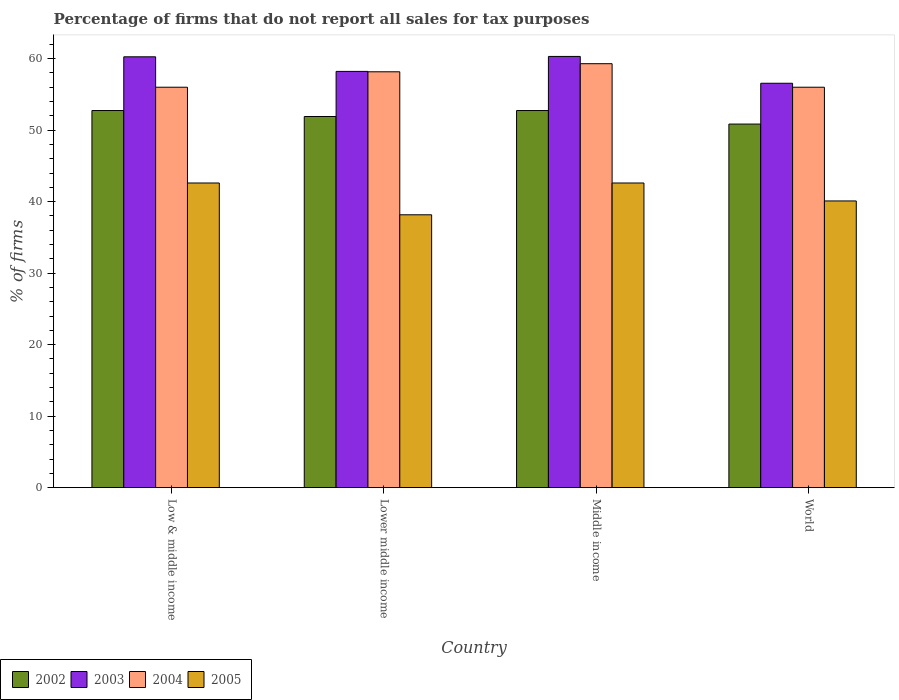How many different coloured bars are there?
Ensure brevity in your answer.  4. Are the number of bars per tick equal to the number of legend labels?
Your answer should be compact. Yes. Are the number of bars on each tick of the X-axis equal?
Your answer should be compact. Yes. How many bars are there on the 3rd tick from the left?
Provide a short and direct response. 4. What is the label of the 3rd group of bars from the left?
Provide a succinct answer. Middle income. What is the percentage of firms that do not report all sales for tax purposes in 2004 in Lower middle income?
Your response must be concise. 58.16. Across all countries, what is the maximum percentage of firms that do not report all sales for tax purposes in 2005?
Offer a very short reply. 42.61. Across all countries, what is the minimum percentage of firms that do not report all sales for tax purposes in 2004?
Your answer should be compact. 56.01. In which country was the percentage of firms that do not report all sales for tax purposes in 2002 minimum?
Offer a very short reply. World. What is the total percentage of firms that do not report all sales for tax purposes in 2003 in the graph?
Your response must be concise. 235.35. What is the difference between the percentage of firms that do not report all sales for tax purposes in 2004 in Lower middle income and that in Middle income?
Provide a succinct answer. -1.13. What is the difference between the percentage of firms that do not report all sales for tax purposes in 2003 in Lower middle income and the percentage of firms that do not report all sales for tax purposes in 2004 in World?
Give a very brief answer. 2.21. What is the average percentage of firms that do not report all sales for tax purposes in 2003 per country?
Offer a terse response. 58.84. What is the difference between the percentage of firms that do not report all sales for tax purposes of/in 2004 and percentage of firms that do not report all sales for tax purposes of/in 2003 in Lower middle income?
Provide a short and direct response. -0.05. In how many countries, is the percentage of firms that do not report all sales for tax purposes in 2002 greater than 18 %?
Give a very brief answer. 4. What is the ratio of the percentage of firms that do not report all sales for tax purposes in 2005 in Low & middle income to that in World?
Your response must be concise. 1.06. What is the difference between the highest and the second highest percentage of firms that do not report all sales for tax purposes in 2005?
Your answer should be very brief. -2.51. What is the difference between the highest and the lowest percentage of firms that do not report all sales for tax purposes in 2002?
Provide a succinct answer. 1.89. In how many countries, is the percentage of firms that do not report all sales for tax purposes in 2003 greater than the average percentage of firms that do not report all sales for tax purposes in 2003 taken over all countries?
Keep it short and to the point. 2. What does the 3rd bar from the left in Middle income represents?
Make the answer very short. 2004. How many bars are there?
Your answer should be very brief. 16. Does the graph contain any zero values?
Provide a succinct answer. No. Does the graph contain grids?
Offer a very short reply. No. Where does the legend appear in the graph?
Ensure brevity in your answer.  Bottom left. What is the title of the graph?
Offer a terse response. Percentage of firms that do not report all sales for tax purposes. Does "1973" appear as one of the legend labels in the graph?
Provide a short and direct response. No. What is the label or title of the X-axis?
Offer a terse response. Country. What is the label or title of the Y-axis?
Make the answer very short. % of firms. What is the % of firms of 2002 in Low & middle income?
Offer a very short reply. 52.75. What is the % of firms in 2003 in Low & middle income?
Give a very brief answer. 60.26. What is the % of firms of 2004 in Low & middle income?
Provide a succinct answer. 56.01. What is the % of firms in 2005 in Low & middle income?
Your answer should be very brief. 42.61. What is the % of firms of 2002 in Lower middle income?
Offer a very short reply. 51.91. What is the % of firms in 2003 in Lower middle income?
Make the answer very short. 58.22. What is the % of firms of 2004 in Lower middle income?
Your answer should be very brief. 58.16. What is the % of firms in 2005 in Lower middle income?
Offer a very short reply. 38.16. What is the % of firms of 2002 in Middle income?
Offer a terse response. 52.75. What is the % of firms of 2003 in Middle income?
Ensure brevity in your answer.  60.31. What is the % of firms of 2004 in Middle income?
Make the answer very short. 59.3. What is the % of firms in 2005 in Middle income?
Give a very brief answer. 42.61. What is the % of firms of 2002 in World?
Your answer should be very brief. 50.85. What is the % of firms in 2003 in World?
Give a very brief answer. 56.56. What is the % of firms in 2004 in World?
Your answer should be very brief. 56.01. What is the % of firms in 2005 in World?
Make the answer very short. 40.1. Across all countries, what is the maximum % of firms of 2002?
Your answer should be very brief. 52.75. Across all countries, what is the maximum % of firms of 2003?
Your answer should be compact. 60.31. Across all countries, what is the maximum % of firms of 2004?
Give a very brief answer. 59.3. Across all countries, what is the maximum % of firms of 2005?
Offer a terse response. 42.61. Across all countries, what is the minimum % of firms of 2002?
Offer a terse response. 50.85. Across all countries, what is the minimum % of firms of 2003?
Your response must be concise. 56.56. Across all countries, what is the minimum % of firms of 2004?
Provide a succinct answer. 56.01. Across all countries, what is the minimum % of firms of 2005?
Your answer should be compact. 38.16. What is the total % of firms in 2002 in the graph?
Keep it short and to the point. 208.25. What is the total % of firms in 2003 in the graph?
Keep it short and to the point. 235.35. What is the total % of firms of 2004 in the graph?
Make the answer very short. 229.47. What is the total % of firms in 2005 in the graph?
Offer a very short reply. 163.48. What is the difference between the % of firms of 2002 in Low & middle income and that in Lower middle income?
Ensure brevity in your answer.  0.84. What is the difference between the % of firms in 2003 in Low & middle income and that in Lower middle income?
Offer a very short reply. 2.04. What is the difference between the % of firms of 2004 in Low & middle income and that in Lower middle income?
Make the answer very short. -2.16. What is the difference between the % of firms in 2005 in Low & middle income and that in Lower middle income?
Offer a terse response. 4.45. What is the difference between the % of firms of 2002 in Low & middle income and that in Middle income?
Make the answer very short. 0. What is the difference between the % of firms of 2003 in Low & middle income and that in Middle income?
Provide a succinct answer. -0.05. What is the difference between the % of firms in 2004 in Low & middle income and that in Middle income?
Keep it short and to the point. -3.29. What is the difference between the % of firms in 2005 in Low & middle income and that in Middle income?
Your answer should be very brief. 0. What is the difference between the % of firms in 2002 in Low & middle income and that in World?
Offer a very short reply. 1.89. What is the difference between the % of firms in 2005 in Low & middle income and that in World?
Ensure brevity in your answer.  2.51. What is the difference between the % of firms in 2002 in Lower middle income and that in Middle income?
Give a very brief answer. -0.84. What is the difference between the % of firms of 2003 in Lower middle income and that in Middle income?
Give a very brief answer. -2.09. What is the difference between the % of firms of 2004 in Lower middle income and that in Middle income?
Provide a short and direct response. -1.13. What is the difference between the % of firms of 2005 in Lower middle income and that in Middle income?
Offer a very short reply. -4.45. What is the difference between the % of firms of 2002 in Lower middle income and that in World?
Your response must be concise. 1.06. What is the difference between the % of firms of 2003 in Lower middle income and that in World?
Your answer should be very brief. 1.66. What is the difference between the % of firms in 2004 in Lower middle income and that in World?
Your answer should be compact. 2.16. What is the difference between the % of firms in 2005 in Lower middle income and that in World?
Provide a succinct answer. -1.94. What is the difference between the % of firms of 2002 in Middle income and that in World?
Keep it short and to the point. 1.89. What is the difference between the % of firms of 2003 in Middle income and that in World?
Offer a terse response. 3.75. What is the difference between the % of firms in 2004 in Middle income and that in World?
Make the answer very short. 3.29. What is the difference between the % of firms of 2005 in Middle income and that in World?
Your answer should be very brief. 2.51. What is the difference between the % of firms of 2002 in Low & middle income and the % of firms of 2003 in Lower middle income?
Make the answer very short. -5.47. What is the difference between the % of firms in 2002 in Low & middle income and the % of firms in 2004 in Lower middle income?
Ensure brevity in your answer.  -5.42. What is the difference between the % of firms of 2002 in Low & middle income and the % of firms of 2005 in Lower middle income?
Your answer should be compact. 14.58. What is the difference between the % of firms in 2003 in Low & middle income and the % of firms in 2004 in Lower middle income?
Ensure brevity in your answer.  2.1. What is the difference between the % of firms in 2003 in Low & middle income and the % of firms in 2005 in Lower middle income?
Provide a succinct answer. 22.1. What is the difference between the % of firms of 2004 in Low & middle income and the % of firms of 2005 in Lower middle income?
Give a very brief answer. 17.84. What is the difference between the % of firms of 2002 in Low & middle income and the % of firms of 2003 in Middle income?
Provide a succinct answer. -7.57. What is the difference between the % of firms of 2002 in Low & middle income and the % of firms of 2004 in Middle income?
Give a very brief answer. -6.55. What is the difference between the % of firms of 2002 in Low & middle income and the % of firms of 2005 in Middle income?
Offer a terse response. 10.13. What is the difference between the % of firms in 2003 in Low & middle income and the % of firms in 2005 in Middle income?
Offer a terse response. 17.65. What is the difference between the % of firms of 2004 in Low & middle income and the % of firms of 2005 in Middle income?
Your answer should be very brief. 13.39. What is the difference between the % of firms in 2002 in Low & middle income and the % of firms in 2003 in World?
Keep it short and to the point. -3.81. What is the difference between the % of firms in 2002 in Low & middle income and the % of firms in 2004 in World?
Provide a succinct answer. -3.26. What is the difference between the % of firms in 2002 in Low & middle income and the % of firms in 2005 in World?
Ensure brevity in your answer.  12.65. What is the difference between the % of firms in 2003 in Low & middle income and the % of firms in 2004 in World?
Offer a very short reply. 4.25. What is the difference between the % of firms in 2003 in Low & middle income and the % of firms in 2005 in World?
Keep it short and to the point. 20.16. What is the difference between the % of firms of 2004 in Low & middle income and the % of firms of 2005 in World?
Your answer should be very brief. 15.91. What is the difference between the % of firms in 2002 in Lower middle income and the % of firms in 2003 in Middle income?
Your response must be concise. -8.4. What is the difference between the % of firms in 2002 in Lower middle income and the % of firms in 2004 in Middle income?
Give a very brief answer. -7.39. What is the difference between the % of firms of 2002 in Lower middle income and the % of firms of 2005 in Middle income?
Ensure brevity in your answer.  9.3. What is the difference between the % of firms of 2003 in Lower middle income and the % of firms of 2004 in Middle income?
Offer a terse response. -1.08. What is the difference between the % of firms of 2003 in Lower middle income and the % of firms of 2005 in Middle income?
Your response must be concise. 15.61. What is the difference between the % of firms of 2004 in Lower middle income and the % of firms of 2005 in Middle income?
Your answer should be compact. 15.55. What is the difference between the % of firms of 2002 in Lower middle income and the % of firms of 2003 in World?
Offer a very short reply. -4.65. What is the difference between the % of firms in 2002 in Lower middle income and the % of firms in 2004 in World?
Provide a short and direct response. -4.1. What is the difference between the % of firms of 2002 in Lower middle income and the % of firms of 2005 in World?
Offer a very short reply. 11.81. What is the difference between the % of firms of 2003 in Lower middle income and the % of firms of 2004 in World?
Give a very brief answer. 2.21. What is the difference between the % of firms of 2003 in Lower middle income and the % of firms of 2005 in World?
Provide a succinct answer. 18.12. What is the difference between the % of firms in 2004 in Lower middle income and the % of firms in 2005 in World?
Offer a terse response. 18.07. What is the difference between the % of firms in 2002 in Middle income and the % of firms in 2003 in World?
Ensure brevity in your answer.  -3.81. What is the difference between the % of firms in 2002 in Middle income and the % of firms in 2004 in World?
Keep it short and to the point. -3.26. What is the difference between the % of firms of 2002 in Middle income and the % of firms of 2005 in World?
Your response must be concise. 12.65. What is the difference between the % of firms of 2003 in Middle income and the % of firms of 2004 in World?
Provide a short and direct response. 4.31. What is the difference between the % of firms in 2003 in Middle income and the % of firms in 2005 in World?
Offer a terse response. 20.21. What is the difference between the % of firms in 2004 in Middle income and the % of firms in 2005 in World?
Offer a terse response. 19.2. What is the average % of firms in 2002 per country?
Provide a short and direct response. 52.06. What is the average % of firms in 2003 per country?
Offer a terse response. 58.84. What is the average % of firms of 2004 per country?
Your answer should be very brief. 57.37. What is the average % of firms in 2005 per country?
Provide a short and direct response. 40.87. What is the difference between the % of firms in 2002 and % of firms in 2003 in Low & middle income?
Keep it short and to the point. -7.51. What is the difference between the % of firms of 2002 and % of firms of 2004 in Low & middle income?
Provide a short and direct response. -3.26. What is the difference between the % of firms of 2002 and % of firms of 2005 in Low & middle income?
Provide a succinct answer. 10.13. What is the difference between the % of firms in 2003 and % of firms in 2004 in Low & middle income?
Keep it short and to the point. 4.25. What is the difference between the % of firms of 2003 and % of firms of 2005 in Low & middle income?
Your answer should be very brief. 17.65. What is the difference between the % of firms in 2004 and % of firms in 2005 in Low & middle income?
Provide a succinct answer. 13.39. What is the difference between the % of firms in 2002 and % of firms in 2003 in Lower middle income?
Give a very brief answer. -6.31. What is the difference between the % of firms of 2002 and % of firms of 2004 in Lower middle income?
Keep it short and to the point. -6.26. What is the difference between the % of firms of 2002 and % of firms of 2005 in Lower middle income?
Provide a succinct answer. 13.75. What is the difference between the % of firms in 2003 and % of firms in 2004 in Lower middle income?
Your response must be concise. 0.05. What is the difference between the % of firms of 2003 and % of firms of 2005 in Lower middle income?
Your answer should be compact. 20.06. What is the difference between the % of firms in 2004 and % of firms in 2005 in Lower middle income?
Provide a short and direct response. 20. What is the difference between the % of firms of 2002 and % of firms of 2003 in Middle income?
Your response must be concise. -7.57. What is the difference between the % of firms in 2002 and % of firms in 2004 in Middle income?
Make the answer very short. -6.55. What is the difference between the % of firms in 2002 and % of firms in 2005 in Middle income?
Keep it short and to the point. 10.13. What is the difference between the % of firms in 2003 and % of firms in 2004 in Middle income?
Keep it short and to the point. 1.02. What is the difference between the % of firms in 2003 and % of firms in 2005 in Middle income?
Provide a short and direct response. 17.7. What is the difference between the % of firms in 2004 and % of firms in 2005 in Middle income?
Keep it short and to the point. 16.69. What is the difference between the % of firms of 2002 and % of firms of 2003 in World?
Ensure brevity in your answer.  -5.71. What is the difference between the % of firms of 2002 and % of firms of 2004 in World?
Make the answer very short. -5.15. What is the difference between the % of firms in 2002 and % of firms in 2005 in World?
Offer a very short reply. 10.75. What is the difference between the % of firms in 2003 and % of firms in 2004 in World?
Provide a short and direct response. 0.56. What is the difference between the % of firms in 2003 and % of firms in 2005 in World?
Your response must be concise. 16.46. What is the difference between the % of firms of 2004 and % of firms of 2005 in World?
Offer a very short reply. 15.91. What is the ratio of the % of firms of 2002 in Low & middle income to that in Lower middle income?
Your answer should be very brief. 1.02. What is the ratio of the % of firms of 2003 in Low & middle income to that in Lower middle income?
Ensure brevity in your answer.  1.04. What is the ratio of the % of firms of 2004 in Low & middle income to that in Lower middle income?
Give a very brief answer. 0.96. What is the ratio of the % of firms of 2005 in Low & middle income to that in Lower middle income?
Provide a short and direct response. 1.12. What is the ratio of the % of firms of 2003 in Low & middle income to that in Middle income?
Your answer should be compact. 1. What is the ratio of the % of firms in 2004 in Low & middle income to that in Middle income?
Your answer should be compact. 0.94. What is the ratio of the % of firms in 2005 in Low & middle income to that in Middle income?
Offer a terse response. 1. What is the ratio of the % of firms of 2002 in Low & middle income to that in World?
Give a very brief answer. 1.04. What is the ratio of the % of firms of 2003 in Low & middle income to that in World?
Offer a very short reply. 1.07. What is the ratio of the % of firms in 2004 in Low & middle income to that in World?
Make the answer very short. 1. What is the ratio of the % of firms in 2005 in Low & middle income to that in World?
Your response must be concise. 1.06. What is the ratio of the % of firms in 2002 in Lower middle income to that in Middle income?
Offer a very short reply. 0.98. What is the ratio of the % of firms in 2003 in Lower middle income to that in Middle income?
Your answer should be very brief. 0.97. What is the ratio of the % of firms in 2004 in Lower middle income to that in Middle income?
Offer a terse response. 0.98. What is the ratio of the % of firms of 2005 in Lower middle income to that in Middle income?
Provide a short and direct response. 0.9. What is the ratio of the % of firms in 2002 in Lower middle income to that in World?
Provide a succinct answer. 1.02. What is the ratio of the % of firms in 2003 in Lower middle income to that in World?
Ensure brevity in your answer.  1.03. What is the ratio of the % of firms of 2004 in Lower middle income to that in World?
Keep it short and to the point. 1.04. What is the ratio of the % of firms in 2005 in Lower middle income to that in World?
Make the answer very short. 0.95. What is the ratio of the % of firms of 2002 in Middle income to that in World?
Your answer should be compact. 1.04. What is the ratio of the % of firms in 2003 in Middle income to that in World?
Your answer should be compact. 1.07. What is the ratio of the % of firms in 2004 in Middle income to that in World?
Your response must be concise. 1.06. What is the ratio of the % of firms in 2005 in Middle income to that in World?
Provide a succinct answer. 1.06. What is the difference between the highest and the second highest % of firms in 2002?
Ensure brevity in your answer.  0. What is the difference between the highest and the second highest % of firms of 2003?
Offer a very short reply. 0.05. What is the difference between the highest and the second highest % of firms in 2004?
Provide a succinct answer. 1.13. What is the difference between the highest and the second highest % of firms in 2005?
Make the answer very short. 0. What is the difference between the highest and the lowest % of firms of 2002?
Ensure brevity in your answer.  1.89. What is the difference between the highest and the lowest % of firms in 2003?
Your answer should be very brief. 3.75. What is the difference between the highest and the lowest % of firms of 2004?
Your answer should be compact. 3.29. What is the difference between the highest and the lowest % of firms of 2005?
Keep it short and to the point. 4.45. 